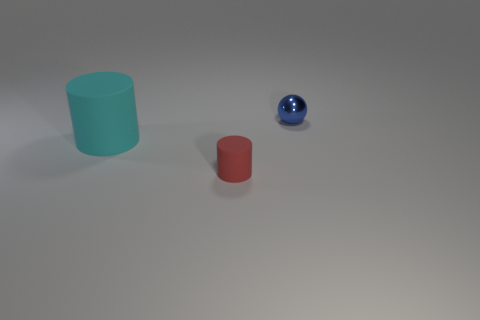What number of other objects are the same shape as the tiny red matte thing? 1 